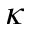Convert formula to latex. <formula><loc_0><loc_0><loc_500><loc_500>\kappa</formula> 